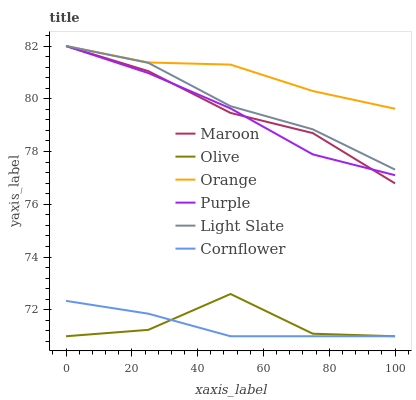Does Cornflower have the minimum area under the curve?
Answer yes or no. Yes. Does Orange have the maximum area under the curve?
Answer yes or no. Yes. Does Purple have the minimum area under the curve?
Answer yes or no. No. Does Purple have the maximum area under the curve?
Answer yes or no. No. Is Cornflower the smoothest?
Answer yes or no. Yes. Is Olive the roughest?
Answer yes or no. Yes. Is Purple the smoothest?
Answer yes or no. No. Is Purple the roughest?
Answer yes or no. No. Does Cornflower have the lowest value?
Answer yes or no. Yes. Does Purple have the lowest value?
Answer yes or no. No. Does Orange have the highest value?
Answer yes or no. Yes. Does Olive have the highest value?
Answer yes or no. No. Is Olive less than Orange?
Answer yes or no. Yes. Is Purple greater than Olive?
Answer yes or no. Yes. Does Purple intersect Orange?
Answer yes or no. Yes. Is Purple less than Orange?
Answer yes or no. No. Is Purple greater than Orange?
Answer yes or no. No. Does Olive intersect Orange?
Answer yes or no. No. 